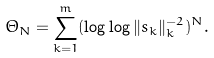<formula> <loc_0><loc_0><loc_500><loc_500>\Theta _ { N } = \sum _ { k = 1 } ^ { m } ( \log \log \| s _ { k } \| _ { k } ^ { - 2 } ) ^ { N } .</formula> 